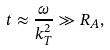<formula> <loc_0><loc_0><loc_500><loc_500>t \approx \frac { \omega } { k _ { T } ^ { 2 } } \gg R _ { A } ,</formula> 